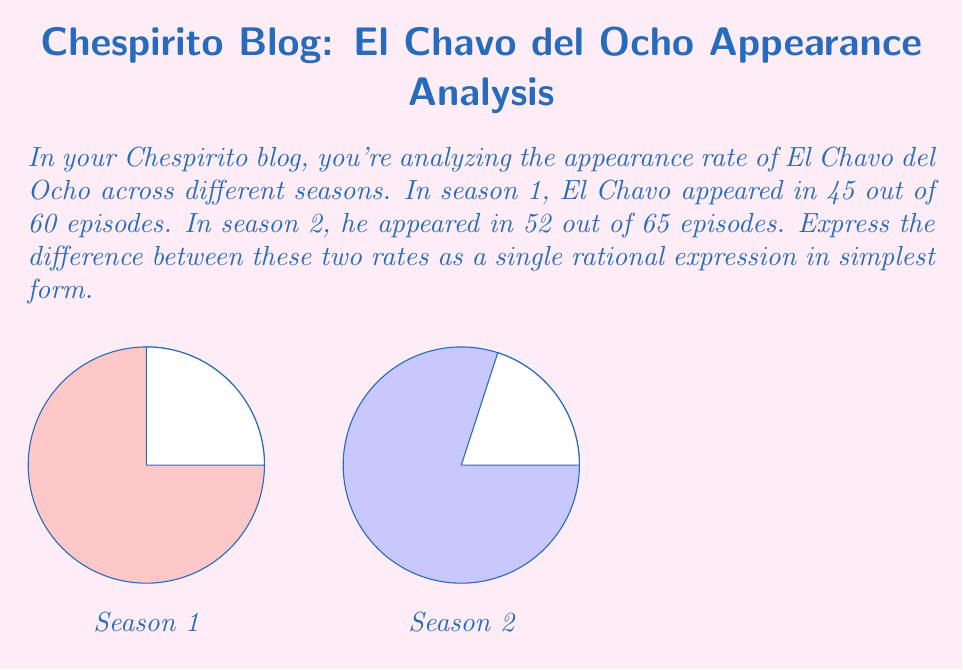Solve this math problem. Let's approach this step-by-step:

1) First, let's calculate the rates for each season:
   Season 1 rate: $\frac{45}{60} = \frac{3}{4}$
   Season 2 rate: $\frac{52}{65} = \frac{4}{5}$

2) Now, we need to find the difference between these rates:
   $\frac{4}{5} - \frac{3}{4}$

3) To subtract fractions, we need a common denominator. The LCM of 5 and 4 is 20:
   $\frac{4 \cdot 4}{5 \cdot 4} - \frac{3 \cdot 5}{4 \cdot 5} = \frac{16}{20} - \frac{15}{20}$

4) Now we can subtract:
   $\frac{16}{20} - \frac{15}{20} = \frac{16-15}{20} = \frac{1}{20}$

5) This fraction is already in its simplest form, so our final answer is $\frac{1}{20}$.
Answer: $\frac{1}{20}$ 